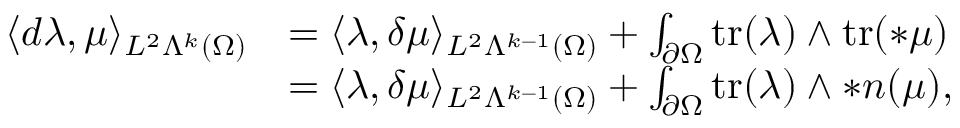Convert formula to latex. <formula><loc_0><loc_0><loc_500><loc_500>\begin{array} { r l } { \langle d \lambda , \mu \rangle _ { L ^ { 2 } \Lambda ^ { k } ( \Omega ) } } & { = \langle \lambda , \delta \mu \rangle _ { L ^ { 2 } \Lambda ^ { k - 1 } ( \Omega ) } + \int _ { \partial \Omega } t r ( \lambda ) \wedge t r ( \ast \mu ) } \\ & { = \langle \lambda , \delta \mu \rangle _ { L ^ { 2 } \Lambda ^ { k - 1 } ( \Omega ) } + \int _ { \partial \Omega } t r ( \lambda ) \wedge \ast n ( \mu ) , } \end{array}</formula> 